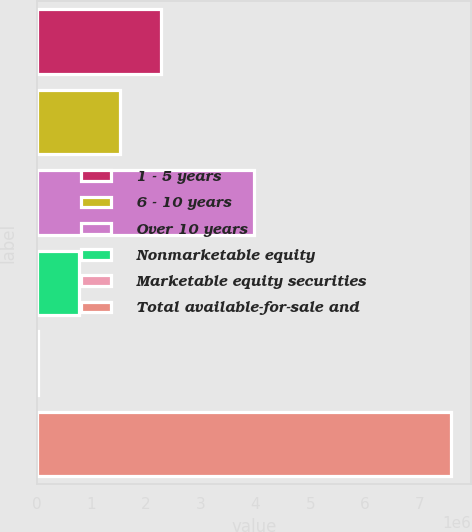Convert chart to OTSL. <chart><loc_0><loc_0><loc_500><loc_500><bar_chart><fcel>1 - 5 years<fcel>6 - 10 years<fcel>Over 10 years<fcel>Nonmarketable equity<fcel>Marketable equity securities<fcel>Total available-for-sale and<nl><fcel>2.28188e+06<fcel>1.52698e+06<fcel>3.9672e+06<fcel>772077<fcel>17177<fcel>7.56618e+06<nl></chart> 